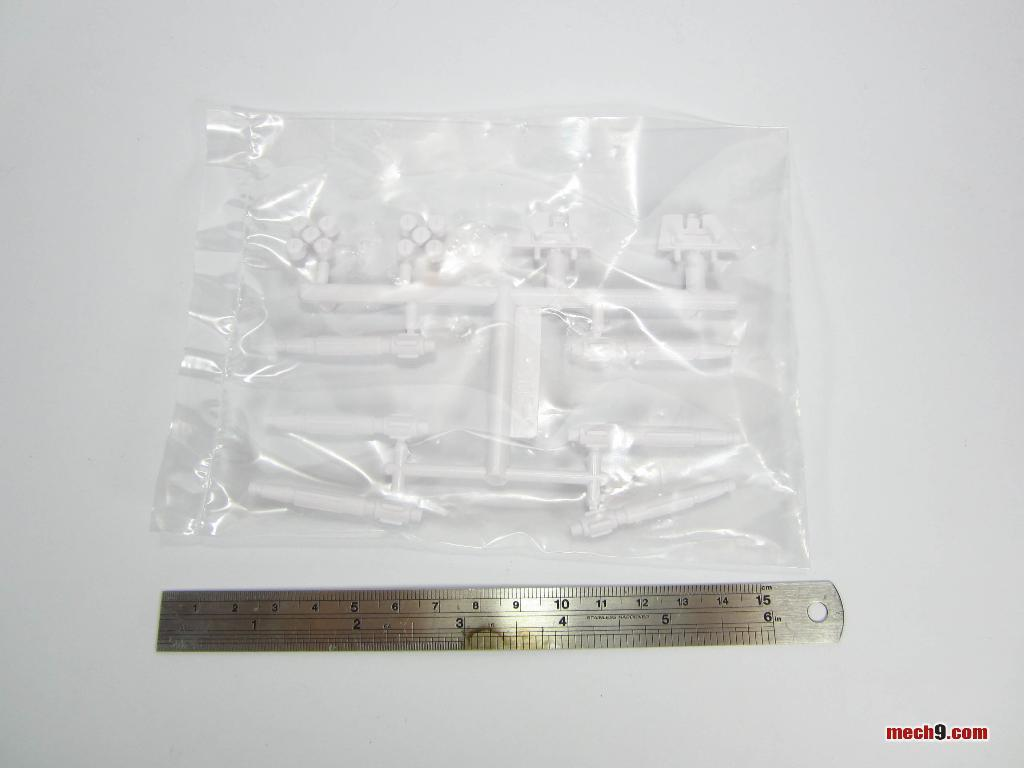Provide a one-sentence caption for the provided image. A metal ruler is next to a bag of white plastic parts and says mech9.com. 